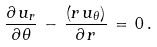<formula> <loc_0><loc_0><loc_500><loc_500>\frac { \partial \, u _ { r } } { \partial \, \theta } \, - \, \frac { \left ( r \, u _ { \theta } \right ) } { \partial \, r } \, = \, 0 \, .</formula> 